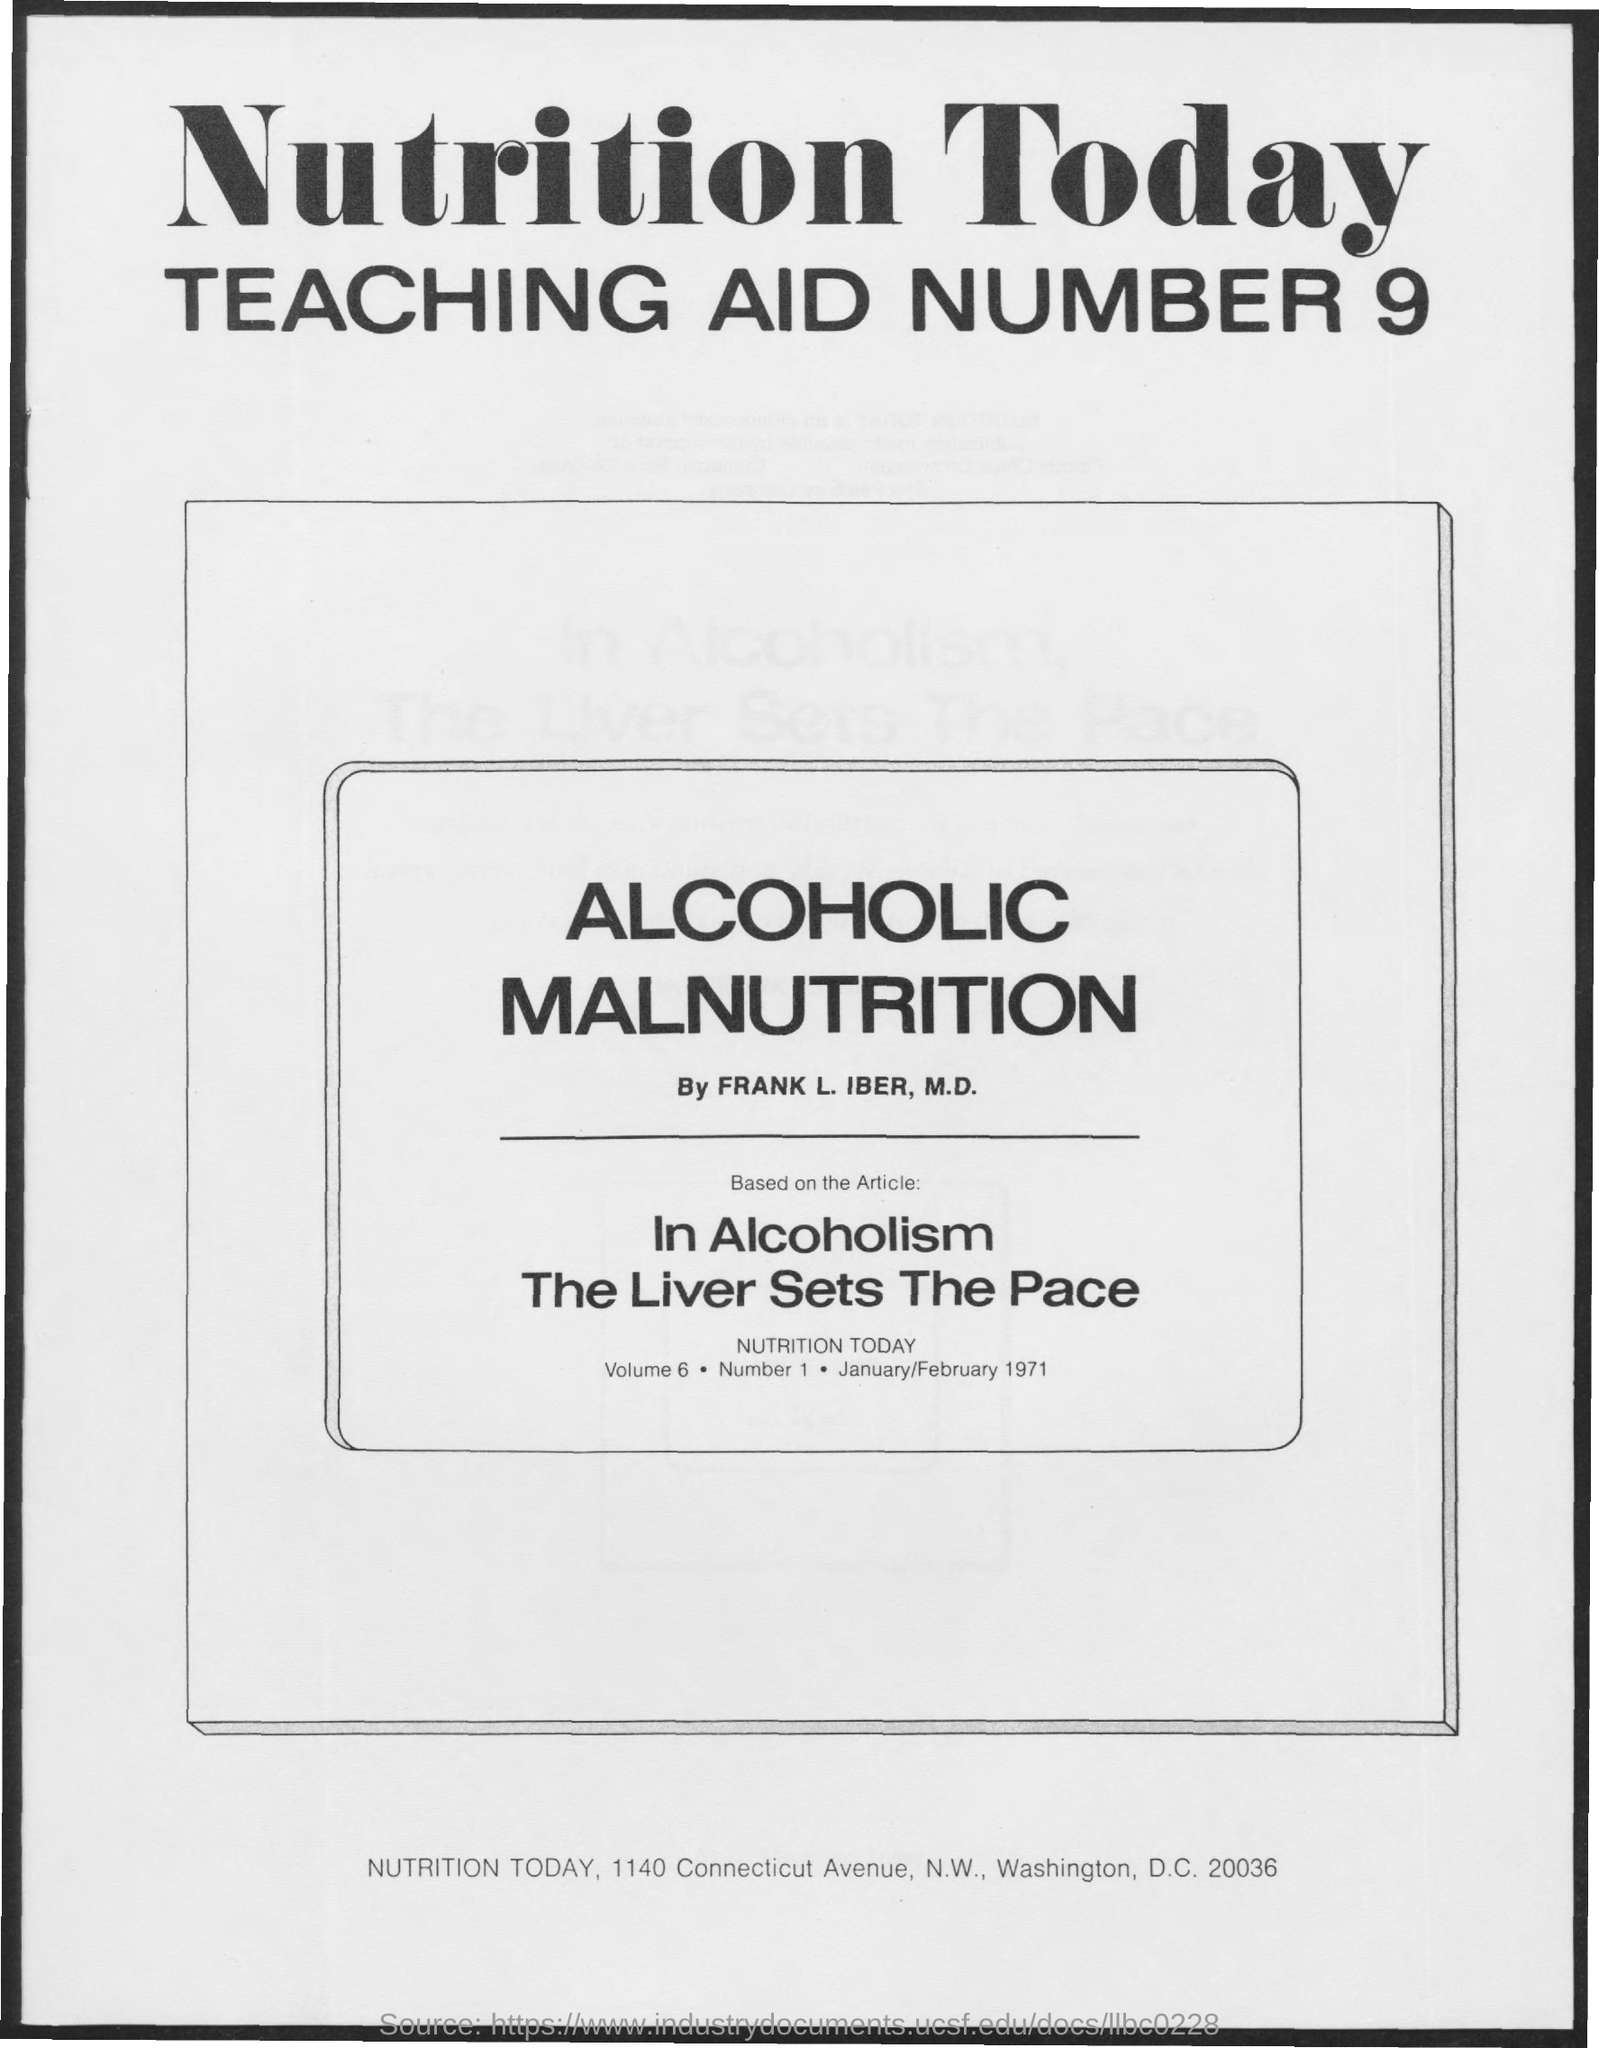Specify some key components in this picture. The volume is 6.. The document contains the date of JANUARY/FEBRUARY 1971. 